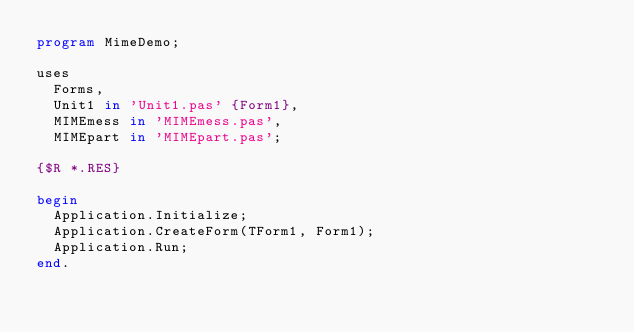<code> <loc_0><loc_0><loc_500><loc_500><_Pascal_>program MimeDemo;

uses
  Forms,
  Unit1 in 'Unit1.pas' {Form1},
  MIMEmess in 'MIMEmess.pas',
  MIMEpart in 'MIMEpart.pas';

{$R *.RES}

begin
  Application.Initialize;
  Application.CreateForm(TForm1, Form1);
  Application.Run;
end.
</code> 